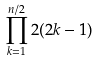Convert formula to latex. <formula><loc_0><loc_0><loc_500><loc_500>\prod _ { k = 1 } ^ { n / 2 } 2 ( 2 k - 1 )</formula> 